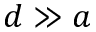Convert formula to latex. <formula><loc_0><loc_0><loc_500><loc_500>d \gg a</formula> 